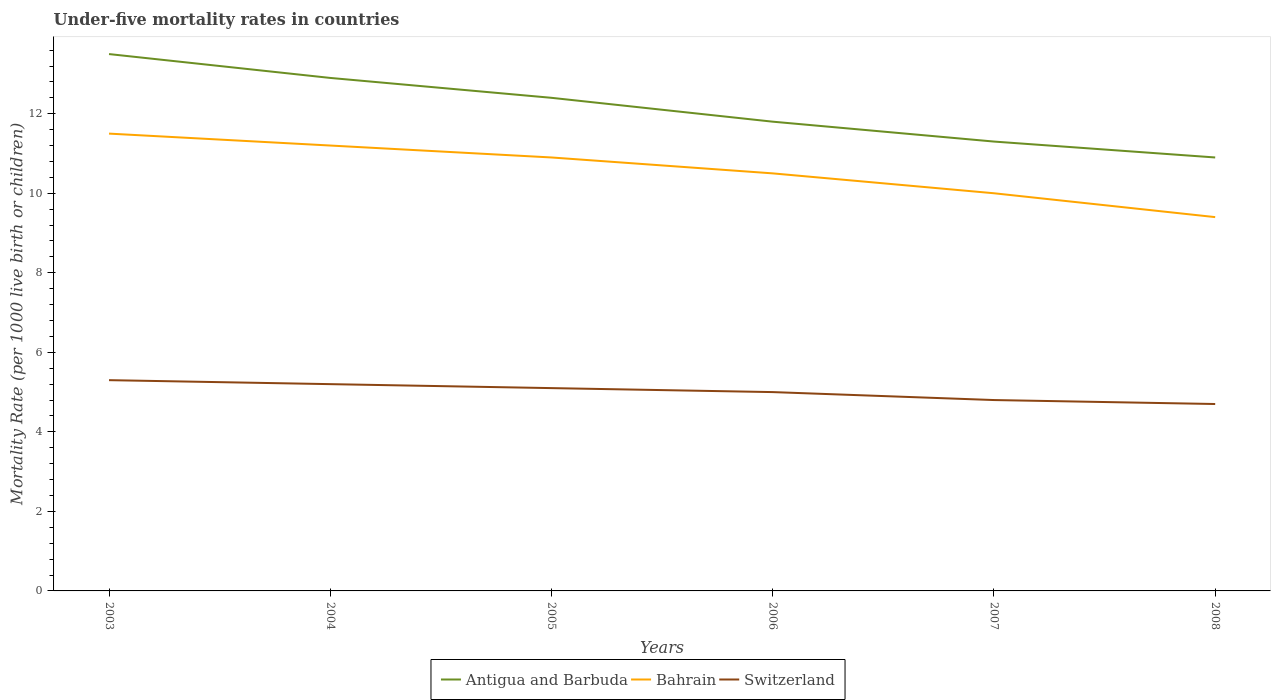How many different coloured lines are there?
Ensure brevity in your answer.  3. Does the line corresponding to Switzerland intersect with the line corresponding to Bahrain?
Offer a terse response. No. Is the number of lines equal to the number of legend labels?
Your response must be concise. Yes. Across all years, what is the maximum under-five mortality rate in Switzerland?
Your answer should be compact. 4.7. In which year was the under-five mortality rate in Switzerland maximum?
Your answer should be very brief. 2008. What is the total under-five mortality rate in Bahrain in the graph?
Offer a terse response. 0.3. What is the difference between the highest and the second highest under-five mortality rate in Bahrain?
Your response must be concise. 2.1. Is the under-five mortality rate in Switzerland strictly greater than the under-five mortality rate in Antigua and Barbuda over the years?
Provide a short and direct response. Yes. How many lines are there?
Your answer should be very brief. 3. Where does the legend appear in the graph?
Offer a very short reply. Bottom center. What is the title of the graph?
Offer a very short reply. Under-five mortality rates in countries. What is the label or title of the Y-axis?
Your answer should be compact. Mortality Rate (per 1000 live birth or children). What is the Mortality Rate (per 1000 live birth or children) in Antigua and Barbuda in 2003?
Keep it short and to the point. 13.5. What is the Mortality Rate (per 1000 live birth or children) in Switzerland in 2003?
Offer a terse response. 5.3. What is the Mortality Rate (per 1000 live birth or children) of Antigua and Barbuda in 2004?
Make the answer very short. 12.9. What is the Mortality Rate (per 1000 live birth or children) in Switzerland in 2004?
Offer a terse response. 5.2. What is the Mortality Rate (per 1000 live birth or children) of Antigua and Barbuda in 2005?
Give a very brief answer. 12.4. What is the Mortality Rate (per 1000 live birth or children) of Antigua and Barbuda in 2006?
Your answer should be compact. 11.8. What is the Mortality Rate (per 1000 live birth or children) in Bahrain in 2006?
Provide a short and direct response. 10.5. What is the Mortality Rate (per 1000 live birth or children) in Bahrain in 2007?
Ensure brevity in your answer.  10. What is the Mortality Rate (per 1000 live birth or children) in Switzerland in 2007?
Offer a terse response. 4.8. Across all years, what is the maximum Mortality Rate (per 1000 live birth or children) in Switzerland?
Provide a succinct answer. 5.3. Across all years, what is the minimum Mortality Rate (per 1000 live birth or children) in Antigua and Barbuda?
Your answer should be compact. 10.9. Across all years, what is the minimum Mortality Rate (per 1000 live birth or children) of Bahrain?
Your response must be concise. 9.4. What is the total Mortality Rate (per 1000 live birth or children) in Antigua and Barbuda in the graph?
Keep it short and to the point. 72.8. What is the total Mortality Rate (per 1000 live birth or children) in Bahrain in the graph?
Your answer should be compact. 63.5. What is the total Mortality Rate (per 1000 live birth or children) in Switzerland in the graph?
Provide a short and direct response. 30.1. What is the difference between the Mortality Rate (per 1000 live birth or children) in Switzerland in 2003 and that in 2004?
Give a very brief answer. 0.1. What is the difference between the Mortality Rate (per 1000 live birth or children) in Antigua and Barbuda in 2003 and that in 2005?
Offer a very short reply. 1.1. What is the difference between the Mortality Rate (per 1000 live birth or children) in Bahrain in 2003 and that in 2005?
Give a very brief answer. 0.6. What is the difference between the Mortality Rate (per 1000 live birth or children) in Antigua and Barbuda in 2003 and that in 2006?
Offer a very short reply. 1.7. What is the difference between the Mortality Rate (per 1000 live birth or children) in Bahrain in 2003 and that in 2006?
Ensure brevity in your answer.  1. What is the difference between the Mortality Rate (per 1000 live birth or children) of Antigua and Barbuda in 2003 and that in 2007?
Give a very brief answer. 2.2. What is the difference between the Mortality Rate (per 1000 live birth or children) of Bahrain in 2003 and that in 2008?
Provide a short and direct response. 2.1. What is the difference between the Mortality Rate (per 1000 live birth or children) of Bahrain in 2004 and that in 2005?
Give a very brief answer. 0.3. What is the difference between the Mortality Rate (per 1000 live birth or children) in Switzerland in 2004 and that in 2005?
Offer a very short reply. 0.1. What is the difference between the Mortality Rate (per 1000 live birth or children) of Antigua and Barbuda in 2004 and that in 2006?
Make the answer very short. 1.1. What is the difference between the Mortality Rate (per 1000 live birth or children) in Switzerland in 2004 and that in 2006?
Your answer should be very brief. 0.2. What is the difference between the Mortality Rate (per 1000 live birth or children) in Switzerland in 2004 and that in 2007?
Keep it short and to the point. 0.4. What is the difference between the Mortality Rate (per 1000 live birth or children) in Antigua and Barbuda in 2004 and that in 2008?
Offer a very short reply. 2. What is the difference between the Mortality Rate (per 1000 live birth or children) of Switzerland in 2004 and that in 2008?
Your answer should be very brief. 0.5. What is the difference between the Mortality Rate (per 1000 live birth or children) in Bahrain in 2005 and that in 2006?
Your answer should be compact. 0.4. What is the difference between the Mortality Rate (per 1000 live birth or children) of Bahrain in 2005 and that in 2007?
Ensure brevity in your answer.  0.9. What is the difference between the Mortality Rate (per 1000 live birth or children) in Switzerland in 2005 and that in 2008?
Give a very brief answer. 0.4. What is the difference between the Mortality Rate (per 1000 live birth or children) in Bahrain in 2006 and that in 2007?
Give a very brief answer. 0.5. What is the difference between the Mortality Rate (per 1000 live birth or children) of Switzerland in 2006 and that in 2007?
Offer a very short reply. 0.2. What is the difference between the Mortality Rate (per 1000 live birth or children) in Antigua and Barbuda in 2006 and that in 2008?
Provide a succinct answer. 0.9. What is the difference between the Mortality Rate (per 1000 live birth or children) of Switzerland in 2006 and that in 2008?
Ensure brevity in your answer.  0.3. What is the difference between the Mortality Rate (per 1000 live birth or children) of Bahrain in 2007 and that in 2008?
Give a very brief answer. 0.6. What is the difference between the Mortality Rate (per 1000 live birth or children) in Switzerland in 2007 and that in 2008?
Your answer should be very brief. 0.1. What is the difference between the Mortality Rate (per 1000 live birth or children) of Bahrain in 2003 and the Mortality Rate (per 1000 live birth or children) of Switzerland in 2004?
Your answer should be compact. 6.3. What is the difference between the Mortality Rate (per 1000 live birth or children) in Bahrain in 2003 and the Mortality Rate (per 1000 live birth or children) in Switzerland in 2005?
Your answer should be very brief. 6.4. What is the difference between the Mortality Rate (per 1000 live birth or children) of Antigua and Barbuda in 2003 and the Mortality Rate (per 1000 live birth or children) of Bahrain in 2006?
Your answer should be very brief. 3. What is the difference between the Mortality Rate (per 1000 live birth or children) of Antigua and Barbuda in 2003 and the Mortality Rate (per 1000 live birth or children) of Switzerland in 2006?
Provide a short and direct response. 8.5. What is the difference between the Mortality Rate (per 1000 live birth or children) in Bahrain in 2003 and the Mortality Rate (per 1000 live birth or children) in Switzerland in 2006?
Make the answer very short. 6.5. What is the difference between the Mortality Rate (per 1000 live birth or children) in Bahrain in 2003 and the Mortality Rate (per 1000 live birth or children) in Switzerland in 2007?
Keep it short and to the point. 6.7. What is the difference between the Mortality Rate (per 1000 live birth or children) in Antigua and Barbuda in 2003 and the Mortality Rate (per 1000 live birth or children) in Switzerland in 2008?
Ensure brevity in your answer.  8.8. What is the difference between the Mortality Rate (per 1000 live birth or children) of Antigua and Barbuda in 2004 and the Mortality Rate (per 1000 live birth or children) of Switzerland in 2005?
Offer a terse response. 7.8. What is the difference between the Mortality Rate (per 1000 live birth or children) of Bahrain in 2004 and the Mortality Rate (per 1000 live birth or children) of Switzerland in 2005?
Provide a succinct answer. 6.1. What is the difference between the Mortality Rate (per 1000 live birth or children) of Antigua and Barbuda in 2004 and the Mortality Rate (per 1000 live birth or children) of Switzerland in 2006?
Ensure brevity in your answer.  7.9. What is the difference between the Mortality Rate (per 1000 live birth or children) of Bahrain in 2004 and the Mortality Rate (per 1000 live birth or children) of Switzerland in 2006?
Offer a terse response. 6.2. What is the difference between the Mortality Rate (per 1000 live birth or children) in Antigua and Barbuda in 2004 and the Mortality Rate (per 1000 live birth or children) in Switzerland in 2007?
Keep it short and to the point. 8.1. What is the difference between the Mortality Rate (per 1000 live birth or children) in Antigua and Barbuda in 2004 and the Mortality Rate (per 1000 live birth or children) in Bahrain in 2008?
Give a very brief answer. 3.5. What is the difference between the Mortality Rate (per 1000 live birth or children) in Bahrain in 2004 and the Mortality Rate (per 1000 live birth or children) in Switzerland in 2008?
Offer a terse response. 6.5. What is the difference between the Mortality Rate (per 1000 live birth or children) in Antigua and Barbuda in 2005 and the Mortality Rate (per 1000 live birth or children) in Bahrain in 2006?
Provide a succinct answer. 1.9. What is the difference between the Mortality Rate (per 1000 live birth or children) of Bahrain in 2005 and the Mortality Rate (per 1000 live birth or children) of Switzerland in 2006?
Keep it short and to the point. 5.9. What is the difference between the Mortality Rate (per 1000 live birth or children) in Antigua and Barbuda in 2005 and the Mortality Rate (per 1000 live birth or children) in Bahrain in 2007?
Provide a succinct answer. 2.4. What is the difference between the Mortality Rate (per 1000 live birth or children) of Antigua and Barbuda in 2005 and the Mortality Rate (per 1000 live birth or children) of Switzerland in 2007?
Your answer should be very brief. 7.6. What is the difference between the Mortality Rate (per 1000 live birth or children) of Antigua and Barbuda in 2006 and the Mortality Rate (per 1000 live birth or children) of Bahrain in 2007?
Give a very brief answer. 1.8. What is the difference between the Mortality Rate (per 1000 live birth or children) of Bahrain in 2006 and the Mortality Rate (per 1000 live birth or children) of Switzerland in 2007?
Ensure brevity in your answer.  5.7. What is the difference between the Mortality Rate (per 1000 live birth or children) of Bahrain in 2006 and the Mortality Rate (per 1000 live birth or children) of Switzerland in 2008?
Keep it short and to the point. 5.8. What is the difference between the Mortality Rate (per 1000 live birth or children) in Antigua and Barbuda in 2007 and the Mortality Rate (per 1000 live birth or children) in Bahrain in 2008?
Ensure brevity in your answer.  1.9. What is the difference between the Mortality Rate (per 1000 live birth or children) in Antigua and Barbuda in 2007 and the Mortality Rate (per 1000 live birth or children) in Switzerland in 2008?
Give a very brief answer. 6.6. What is the difference between the Mortality Rate (per 1000 live birth or children) in Bahrain in 2007 and the Mortality Rate (per 1000 live birth or children) in Switzerland in 2008?
Provide a short and direct response. 5.3. What is the average Mortality Rate (per 1000 live birth or children) of Antigua and Barbuda per year?
Offer a terse response. 12.13. What is the average Mortality Rate (per 1000 live birth or children) of Bahrain per year?
Keep it short and to the point. 10.58. What is the average Mortality Rate (per 1000 live birth or children) in Switzerland per year?
Your answer should be very brief. 5.02. In the year 2003, what is the difference between the Mortality Rate (per 1000 live birth or children) in Antigua and Barbuda and Mortality Rate (per 1000 live birth or children) in Bahrain?
Provide a succinct answer. 2. In the year 2004, what is the difference between the Mortality Rate (per 1000 live birth or children) in Antigua and Barbuda and Mortality Rate (per 1000 live birth or children) in Switzerland?
Your answer should be very brief. 7.7. In the year 2004, what is the difference between the Mortality Rate (per 1000 live birth or children) in Bahrain and Mortality Rate (per 1000 live birth or children) in Switzerland?
Your answer should be compact. 6. In the year 2005, what is the difference between the Mortality Rate (per 1000 live birth or children) in Antigua and Barbuda and Mortality Rate (per 1000 live birth or children) in Switzerland?
Your answer should be compact. 7.3. In the year 2006, what is the difference between the Mortality Rate (per 1000 live birth or children) of Antigua and Barbuda and Mortality Rate (per 1000 live birth or children) of Bahrain?
Your answer should be very brief. 1.3. In the year 2006, what is the difference between the Mortality Rate (per 1000 live birth or children) in Antigua and Barbuda and Mortality Rate (per 1000 live birth or children) in Switzerland?
Give a very brief answer. 6.8. In the year 2006, what is the difference between the Mortality Rate (per 1000 live birth or children) in Bahrain and Mortality Rate (per 1000 live birth or children) in Switzerland?
Give a very brief answer. 5.5. In the year 2008, what is the difference between the Mortality Rate (per 1000 live birth or children) of Antigua and Barbuda and Mortality Rate (per 1000 live birth or children) of Switzerland?
Your answer should be very brief. 6.2. What is the ratio of the Mortality Rate (per 1000 live birth or children) in Antigua and Barbuda in 2003 to that in 2004?
Ensure brevity in your answer.  1.05. What is the ratio of the Mortality Rate (per 1000 live birth or children) in Bahrain in 2003 to that in 2004?
Offer a terse response. 1.03. What is the ratio of the Mortality Rate (per 1000 live birth or children) of Switzerland in 2003 to that in 2004?
Ensure brevity in your answer.  1.02. What is the ratio of the Mortality Rate (per 1000 live birth or children) of Antigua and Barbuda in 2003 to that in 2005?
Ensure brevity in your answer.  1.09. What is the ratio of the Mortality Rate (per 1000 live birth or children) in Bahrain in 2003 to that in 2005?
Make the answer very short. 1.05. What is the ratio of the Mortality Rate (per 1000 live birth or children) in Switzerland in 2003 to that in 2005?
Provide a succinct answer. 1.04. What is the ratio of the Mortality Rate (per 1000 live birth or children) of Antigua and Barbuda in 2003 to that in 2006?
Your answer should be compact. 1.14. What is the ratio of the Mortality Rate (per 1000 live birth or children) in Bahrain in 2003 to that in 2006?
Your answer should be compact. 1.1. What is the ratio of the Mortality Rate (per 1000 live birth or children) of Switzerland in 2003 to that in 2006?
Provide a short and direct response. 1.06. What is the ratio of the Mortality Rate (per 1000 live birth or children) of Antigua and Barbuda in 2003 to that in 2007?
Make the answer very short. 1.19. What is the ratio of the Mortality Rate (per 1000 live birth or children) in Bahrain in 2003 to that in 2007?
Offer a terse response. 1.15. What is the ratio of the Mortality Rate (per 1000 live birth or children) of Switzerland in 2003 to that in 2007?
Your answer should be very brief. 1.1. What is the ratio of the Mortality Rate (per 1000 live birth or children) of Antigua and Barbuda in 2003 to that in 2008?
Your response must be concise. 1.24. What is the ratio of the Mortality Rate (per 1000 live birth or children) of Bahrain in 2003 to that in 2008?
Your answer should be very brief. 1.22. What is the ratio of the Mortality Rate (per 1000 live birth or children) in Switzerland in 2003 to that in 2008?
Offer a terse response. 1.13. What is the ratio of the Mortality Rate (per 1000 live birth or children) of Antigua and Barbuda in 2004 to that in 2005?
Keep it short and to the point. 1.04. What is the ratio of the Mortality Rate (per 1000 live birth or children) of Bahrain in 2004 to that in 2005?
Provide a succinct answer. 1.03. What is the ratio of the Mortality Rate (per 1000 live birth or children) in Switzerland in 2004 to that in 2005?
Your answer should be very brief. 1.02. What is the ratio of the Mortality Rate (per 1000 live birth or children) of Antigua and Barbuda in 2004 to that in 2006?
Provide a short and direct response. 1.09. What is the ratio of the Mortality Rate (per 1000 live birth or children) in Bahrain in 2004 to that in 2006?
Ensure brevity in your answer.  1.07. What is the ratio of the Mortality Rate (per 1000 live birth or children) in Switzerland in 2004 to that in 2006?
Your response must be concise. 1.04. What is the ratio of the Mortality Rate (per 1000 live birth or children) in Antigua and Barbuda in 2004 to that in 2007?
Provide a short and direct response. 1.14. What is the ratio of the Mortality Rate (per 1000 live birth or children) in Bahrain in 2004 to that in 2007?
Your answer should be very brief. 1.12. What is the ratio of the Mortality Rate (per 1000 live birth or children) in Antigua and Barbuda in 2004 to that in 2008?
Your answer should be very brief. 1.18. What is the ratio of the Mortality Rate (per 1000 live birth or children) in Bahrain in 2004 to that in 2008?
Your response must be concise. 1.19. What is the ratio of the Mortality Rate (per 1000 live birth or children) of Switzerland in 2004 to that in 2008?
Offer a very short reply. 1.11. What is the ratio of the Mortality Rate (per 1000 live birth or children) of Antigua and Barbuda in 2005 to that in 2006?
Your answer should be compact. 1.05. What is the ratio of the Mortality Rate (per 1000 live birth or children) of Bahrain in 2005 to that in 2006?
Make the answer very short. 1.04. What is the ratio of the Mortality Rate (per 1000 live birth or children) of Antigua and Barbuda in 2005 to that in 2007?
Your answer should be very brief. 1.1. What is the ratio of the Mortality Rate (per 1000 live birth or children) in Bahrain in 2005 to that in 2007?
Ensure brevity in your answer.  1.09. What is the ratio of the Mortality Rate (per 1000 live birth or children) in Switzerland in 2005 to that in 2007?
Your answer should be very brief. 1.06. What is the ratio of the Mortality Rate (per 1000 live birth or children) in Antigua and Barbuda in 2005 to that in 2008?
Your answer should be compact. 1.14. What is the ratio of the Mortality Rate (per 1000 live birth or children) of Bahrain in 2005 to that in 2008?
Give a very brief answer. 1.16. What is the ratio of the Mortality Rate (per 1000 live birth or children) in Switzerland in 2005 to that in 2008?
Your answer should be very brief. 1.09. What is the ratio of the Mortality Rate (per 1000 live birth or children) in Antigua and Barbuda in 2006 to that in 2007?
Your response must be concise. 1.04. What is the ratio of the Mortality Rate (per 1000 live birth or children) in Bahrain in 2006 to that in 2007?
Your answer should be very brief. 1.05. What is the ratio of the Mortality Rate (per 1000 live birth or children) of Switzerland in 2006 to that in 2007?
Provide a short and direct response. 1.04. What is the ratio of the Mortality Rate (per 1000 live birth or children) in Antigua and Barbuda in 2006 to that in 2008?
Offer a very short reply. 1.08. What is the ratio of the Mortality Rate (per 1000 live birth or children) in Bahrain in 2006 to that in 2008?
Your response must be concise. 1.12. What is the ratio of the Mortality Rate (per 1000 live birth or children) in Switzerland in 2006 to that in 2008?
Offer a very short reply. 1.06. What is the ratio of the Mortality Rate (per 1000 live birth or children) in Antigua and Barbuda in 2007 to that in 2008?
Your response must be concise. 1.04. What is the ratio of the Mortality Rate (per 1000 live birth or children) in Bahrain in 2007 to that in 2008?
Offer a very short reply. 1.06. What is the ratio of the Mortality Rate (per 1000 live birth or children) in Switzerland in 2007 to that in 2008?
Your response must be concise. 1.02. What is the difference between the highest and the second highest Mortality Rate (per 1000 live birth or children) of Antigua and Barbuda?
Ensure brevity in your answer.  0.6. What is the difference between the highest and the lowest Mortality Rate (per 1000 live birth or children) of Bahrain?
Keep it short and to the point. 2.1. 